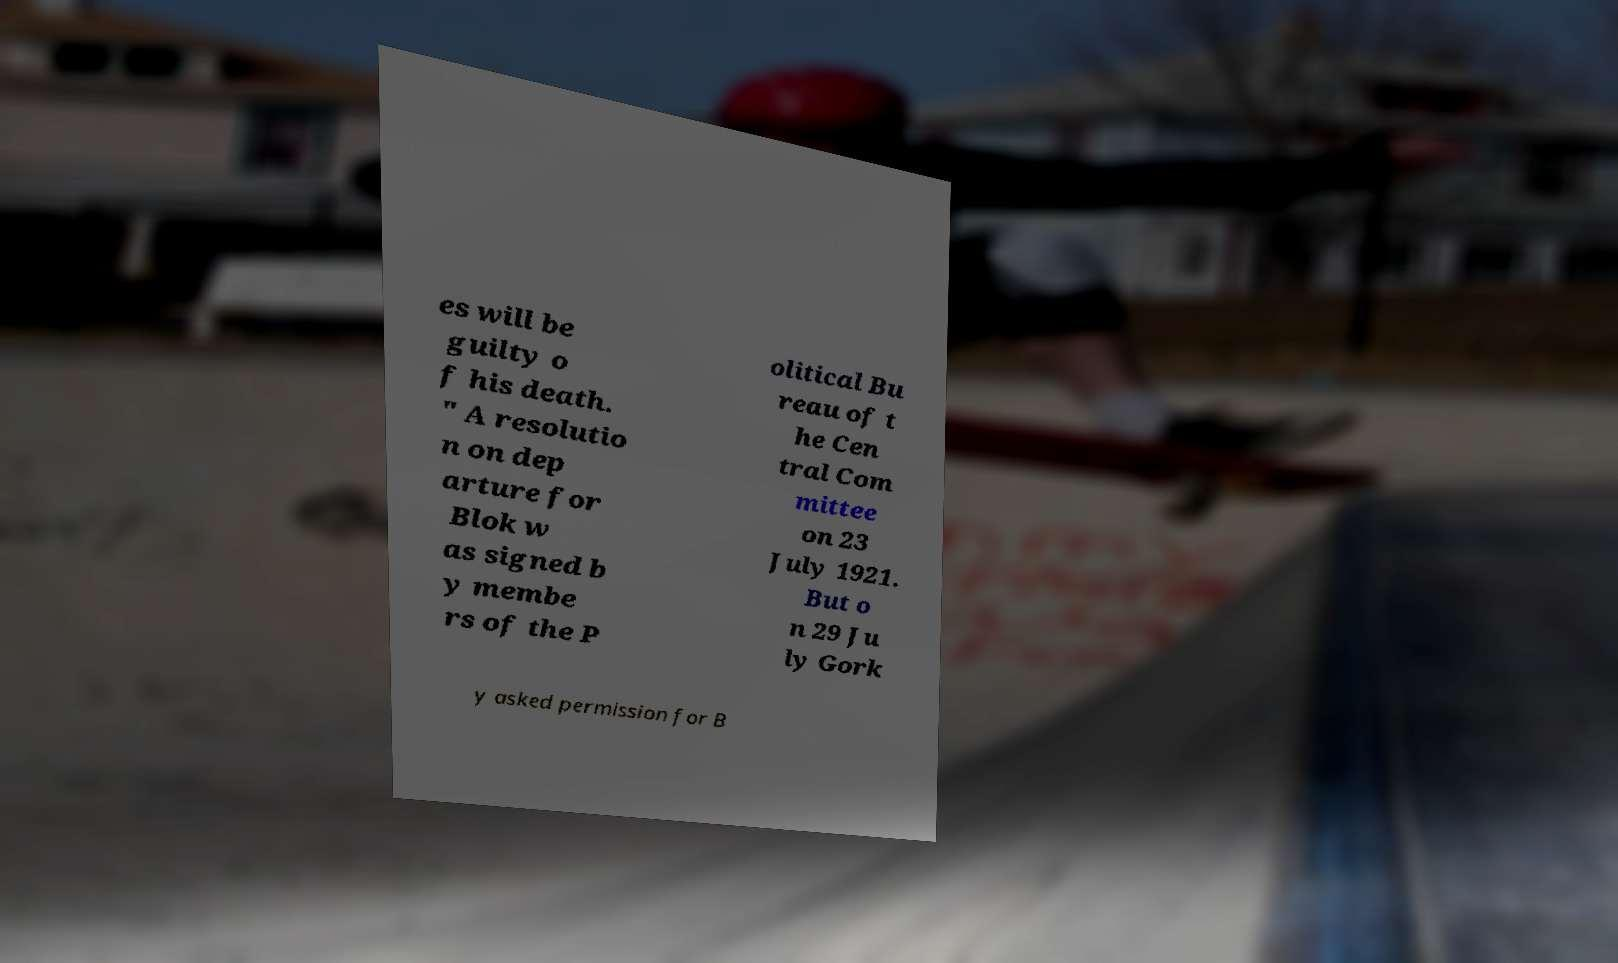Please identify and transcribe the text found in this image. es will be guilty o f his death. " A resolutio n on dep arture for Blok w as signed b y membe rs of the P olitical Bu reau of t he Cen tral Com mittee on 23 July 1921. But o n 29 Ju ly Gork y asked permission for B 